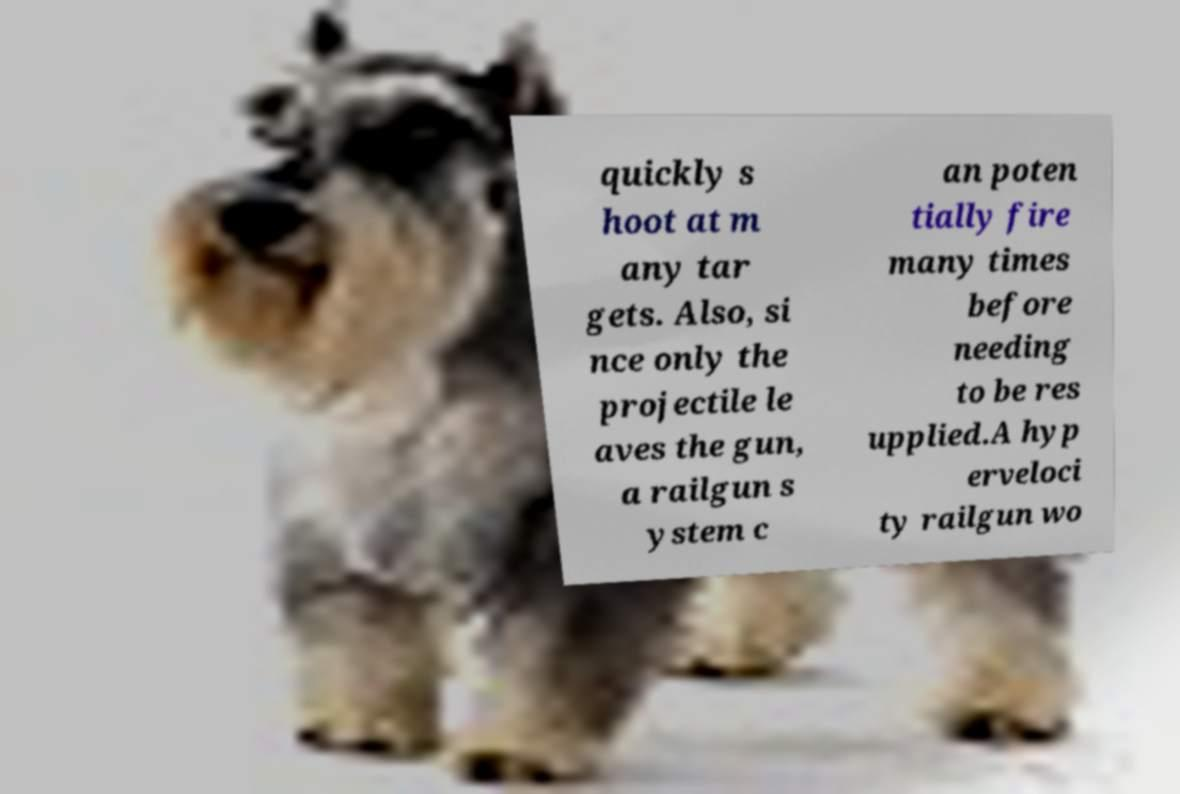Please identify and transcribe the text found in this image. quickly s hoot at m any tar gets. Also, si nce only the projectile le aves the gun, a railgun s ystem c an poten tially fire many times before needing to be res upplied.A hyp erveloci ty railgun wo 